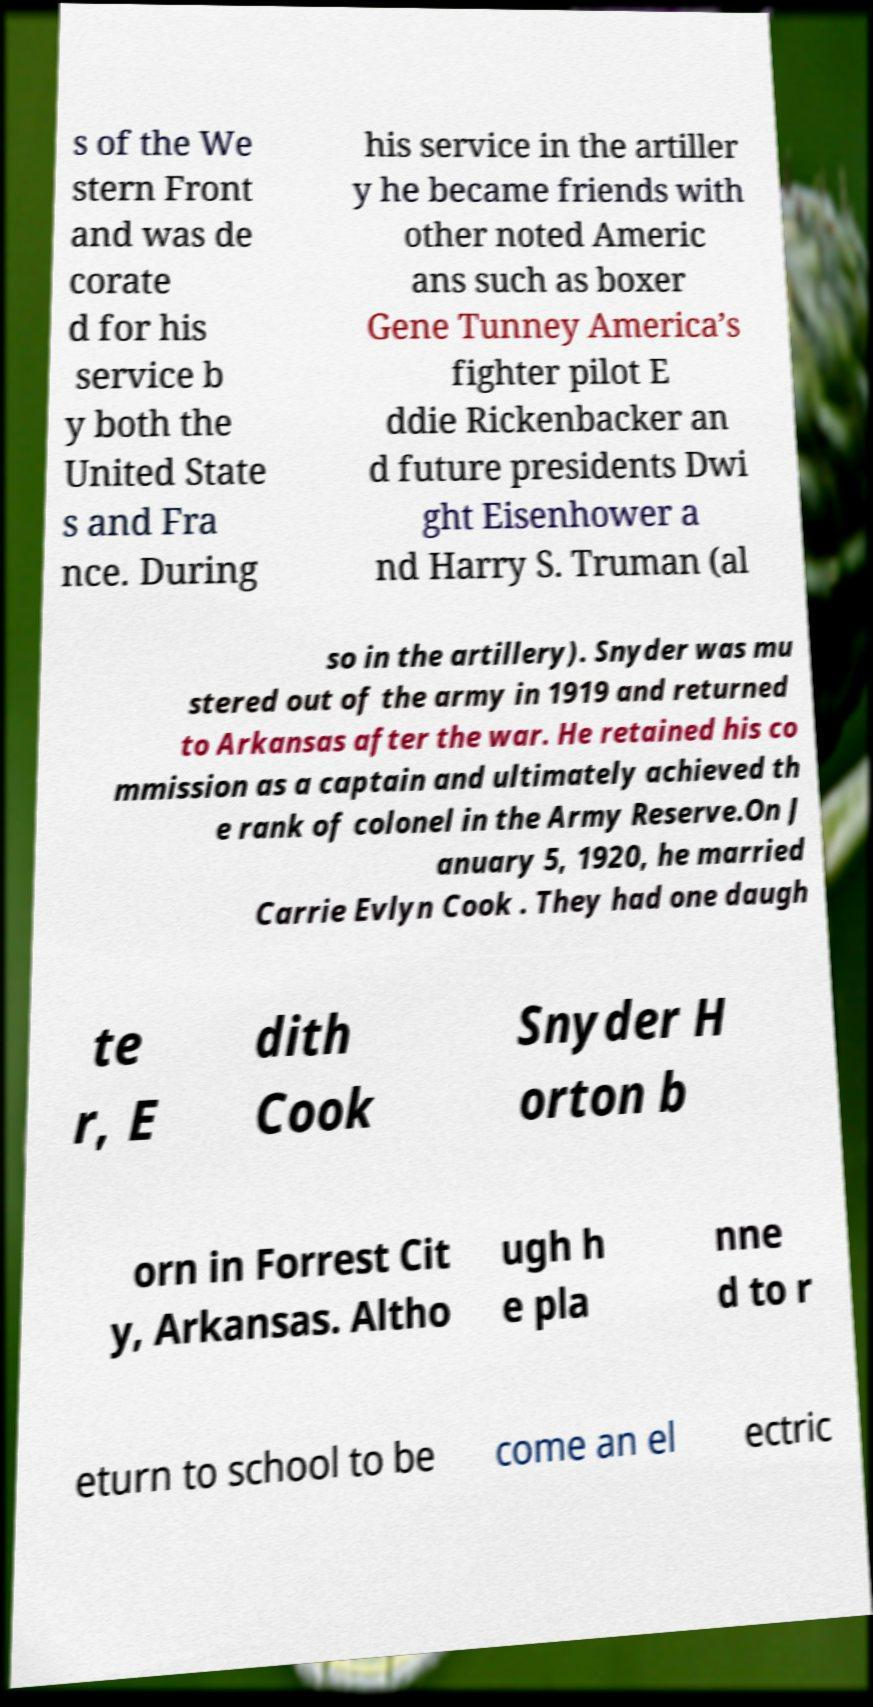I need the written content from this picture converted into text. Can you do that? s of the We stern Front and was de corate d for his service b y both the United State s and Fra nce. During his service in the artiller y he became friends with other noted Americ ans such as boxer Gene Tunney America’s fighter pilot E ddie Rickenbacker an d future presidents Dwi ght Eisenhower a nd Harry S. Truman (al so in the artillery). Snyder was mu stered out of the army in 1919 and returned to Arkansas after the war. He retained his co mmission as a captain and ultimately achieved th e rank of colonel in the Army Reserve.On J anuary 5, 1920, he married Carrie Evlyn Cook . They had one daugh te r, E dith Cook Snyder H orton b orn in Forrest Cit y, Arkansas. Altho ugh h e pla nne d to r eturn to school to be come an el ectric 